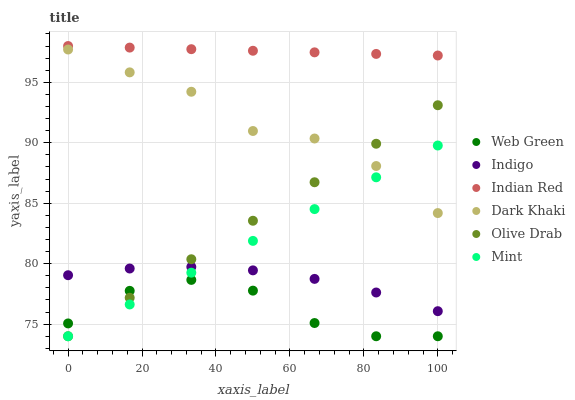Does Web Green have the minimum area under the curve?
Answer yes or no. Yes. Does Indian Red have the maximum area under the curve?
Answer yes or no. Yes. Does Dark Khaki have the minimum area under the curve?
Answer yes or no. No. Does Dark Khaki have the maximum area under the curve?
Answer yes or no. No. Is Olive Drab the smoothest?
Answer yes or no. Yes. Is Web Green the roughest?
Answer yes or no. Yes. Is Dark Khaki the smoothest?
Answer yes or no. No. Is Dark Khaki the roughest?
Answer yes or no. No. Does Web Green have the lowest value?
Answer yes or no. Yes. Does Dark Khaki have the lowest value?
Answer yes or no. No. Does Indian Red have the highest value?
Answer yes or no. Yes. Does Dark Khaki have the highest value?
Answer yes or no. No. Is Dark Khaki less than Indian Red?
Answer yes or no. Yes. Is Indian Red greater than Dark Khaki?
Answer yes or no. Yes. Does Olive Drab intersect Web Green?
Answer yes or no. Yes. Is Olive Drab less than Web Green?
Answer yes or no. No. Is Olive Drab greater than Web Green?
Answer yes or no. No. Does Dark Khaki intersect Indian Red?
Answer yes or no. No. 